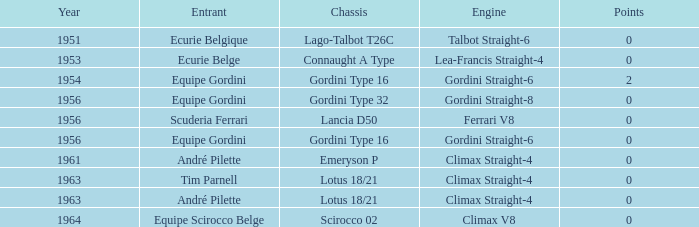Who used Gordini Straight-6 in 1956? Equipe Gordini. 